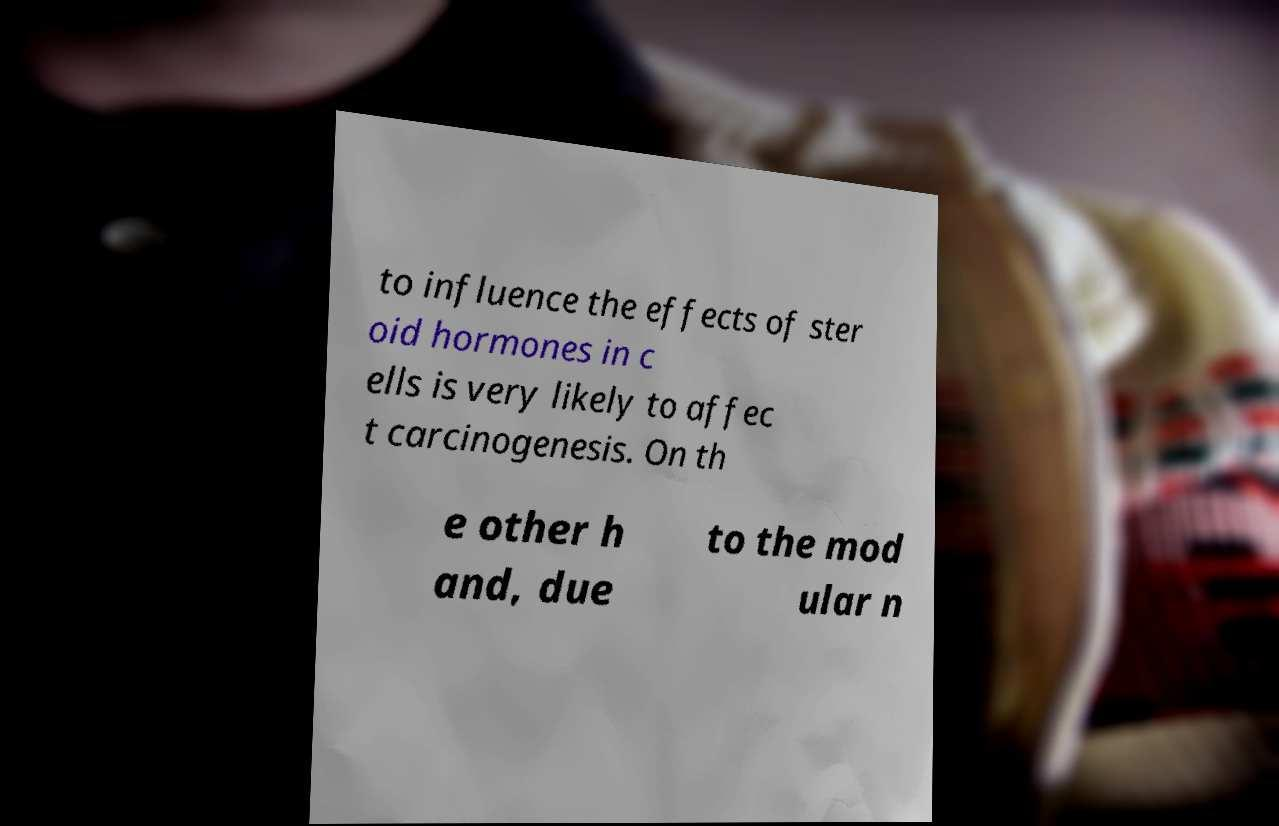Could you extract and type out the text from this image? to influence the effects of ster oid hormones in c ells is very likely to affec t carcinogenesis. On th e other h and, due to the mod ular n 